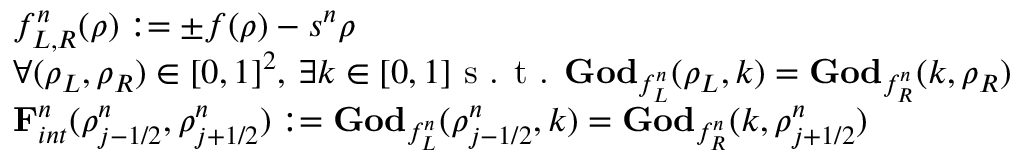Convert formula to latex. <formula><loc_0><loc_0><loc_500><loc_500>\begin{array} { r l } & { f _ { L , R } ^ { n } ( \rho ) \colon = \pm f ( \rho ) - s ^ { n } \rho } \\ & { \forall ( \rho _ { L } , \rho _ { R } ) \in [ 0 , 1 ] ^ { 2 } , \, \exists k \in [ 0 , 1 ] s . t . G o d _ { f _ { L } ^ { n } } ( \rho _ { L } , k ) = G o d _ { f _ { R } ^ { n } } ( k , \rho _ { R } ) } \\ & { F _ { i n t } ^ { n } ( \rho _ { j - 1 / 2 } ^ { n } , \rho _ { j + 1 / 2 } ^ { n } ) \colon = G o d _ { f _ { L } ^ { n } } ( \rho _ { j - 1 / 2 } ^ { n } , k ) = G o d _ { f _ { R } ^ { n } } ( k , \rho _ { j + 1 / 2 } ^ { n } ) } \end{array}</formula> 